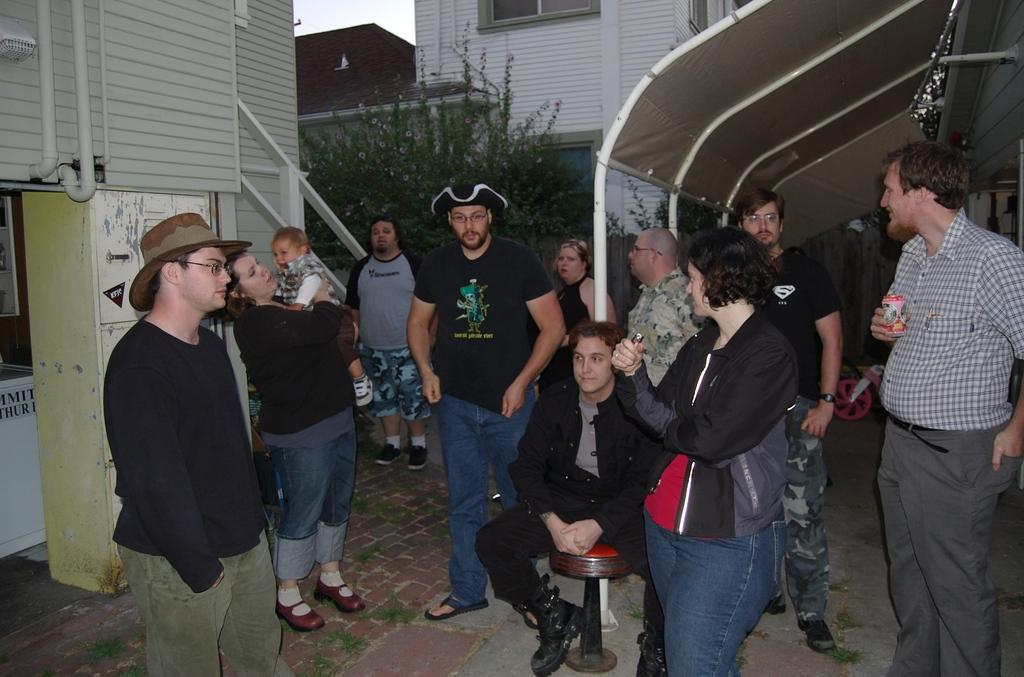What are the people in the image doing? The people in the image are standing. Is there anyone sitting in the image? Yes, there is a person sitting on a stool in the image. What can be seen in the background of the image? In the background of the image, there is a building, plants, the sky, and other objects. How many fingers can be seen holding a fruit in the image? There is no fruit or fingers holding a fruit present in the image. What type of babies are visible in the image? There are no babies present in the image. 